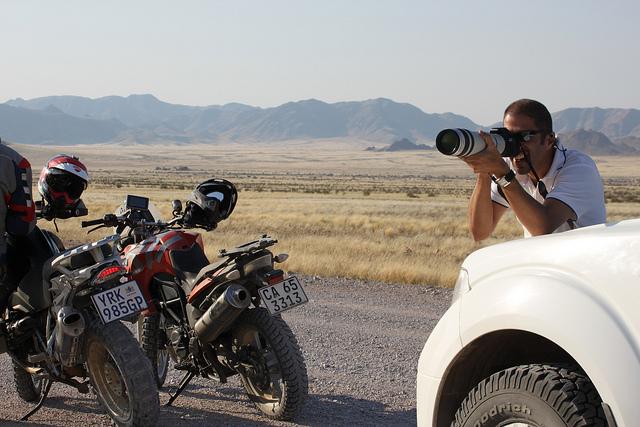What color is the vehicle the man is leaning on?
Write a very short answer. White. How many motorcycles are parked?
Give a very brief answer. 2. What is the man holding?
Answer briefly. Camera. 